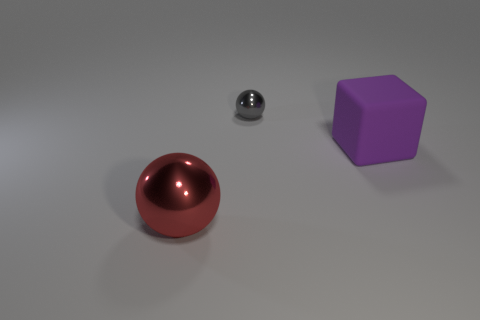What materials do the objects seem to be made of? The sphere appears to have a shiny, reflective surface indicative of a metallic material, possibly steel or polished chrome. The cube, with its matte finish, suggests a plastic or rubber-like composition. 